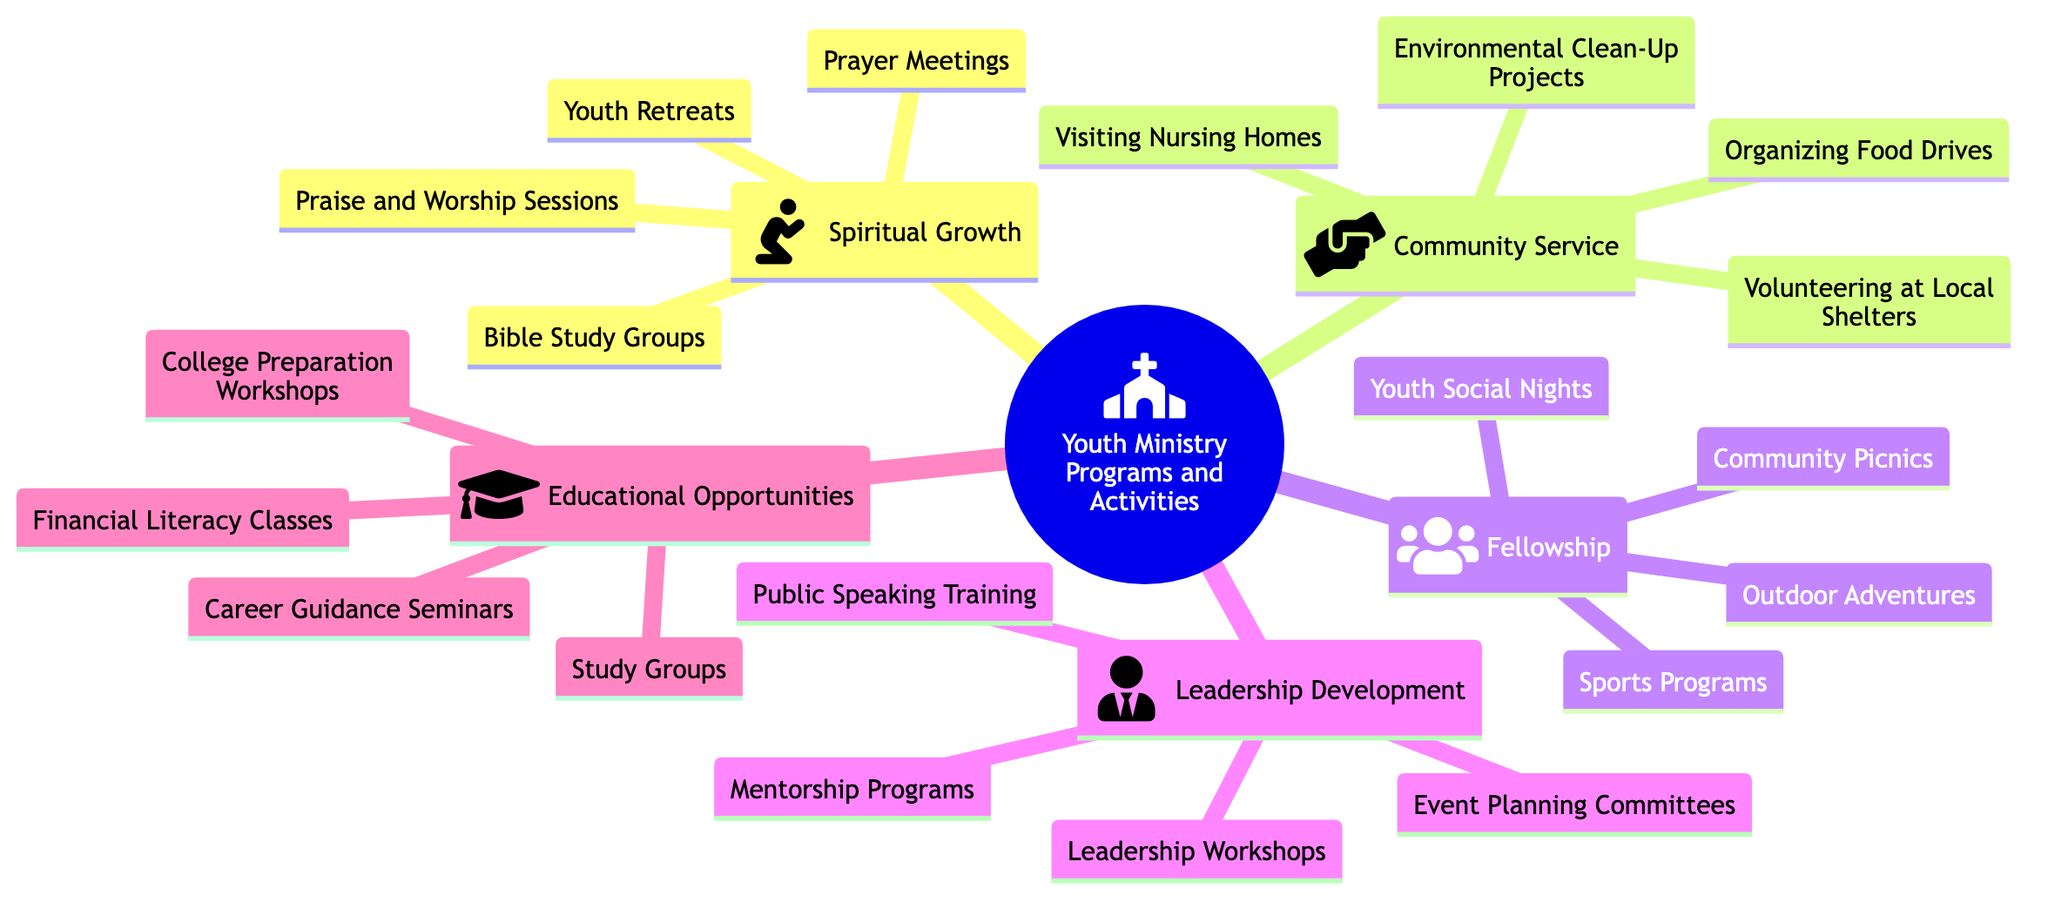What is the main topic of the Mind Map? The main topic is the central node and can be found at the top of the diagram. It is labeled as "Youth Ministry Programs and Activities".
Answer: Youth Ministry Programs and Activities How many subtopics are in the Mind Map? To find the number of subtopics, count the categories listed directly under the main topic, which are Spiritual Growth, Community Service, Fellowship, Leadership Development, and Educational Opportunities. This totals five subtopics.
Answer: 5 List one activity under Community Service. Review the activities listed under the Community Service subtopic, which include Volunteering at Local Shelters, Organizing Food Drives, Environmental Clean-Up Projects, and Visiting Nursing Homes. Any one of these can be a valid answer.
Answer: Volunteering at Local Shelters Which subtopic contains "Bible Study Groups"? The activity "Bible Study Groups" is found under the Spiritual Growth subtopic, as specified by the structure of the Mind Map.
Answer: Spiritual Growth What type of activities are included under Leadership Development? Leadership Development includes activities aimed at enhancing skills and abilities, specifically, Mentorship Programs, Leadership Workshops, Public Speaking Training, and Event Planning Committees, as outlined in the diagram.
Answer: Mentorship Programs How many activities are listed under Fellowship? Count the number of activities listed in the Fellowship subtopic: Youth Social Nights, Sports Programs, Outdoor Adventures, and Community Picnics, which totals four activities.
Answer: 4 Which activity is associated with Educational Opportunities? Looking at the Educational Opportunities subtopic, it includes activities like Career Guidance Seminars, College Preparation Workshops, Financial Literacy Classes, and Study Groups. Any one of these would be a correct response.
Answer: Financial Literacy Classes Name the subtopic that focuses on outdoor activities. The Fellowship subtopic comprises various social and outdoor activities, including Youth Social Nights, Sports Programs, Outdoor Adventures, and Community Picnics. Therefore, the subtopic related to outdoor activities is Fellowship.
Answer: Fellowship 